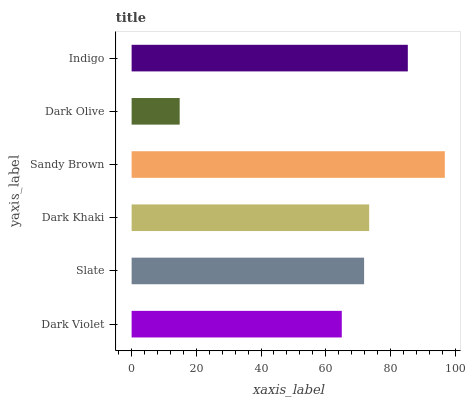Is Dark Olive the minimum?
Answer yes or no. Yes. Is Sandy Brown the maximum?
Answer yes or no. Yes. Is Slate the minimum?
Answer yes or no. No. Is Slate the maximum?
Answer yes or no. No. Is Slate greater than Dark Violet?
Answer yes or no. Yes. Is Dark Violet less than Slate?
Answer yes or no. Yes. Is Dark Violet greater than Slate?
Answer yes or no. No. Is Slate less than Dark Violet?
Answer yes or no. No. Is Dark Khaki the high median?
Answer yes or no. Yes. Is Slate the low median?
Answer yes or no. Yes. Is Slate the high median?
Answer yes or no. No. Is Indigo the low median?
Answer yes or no. No. 